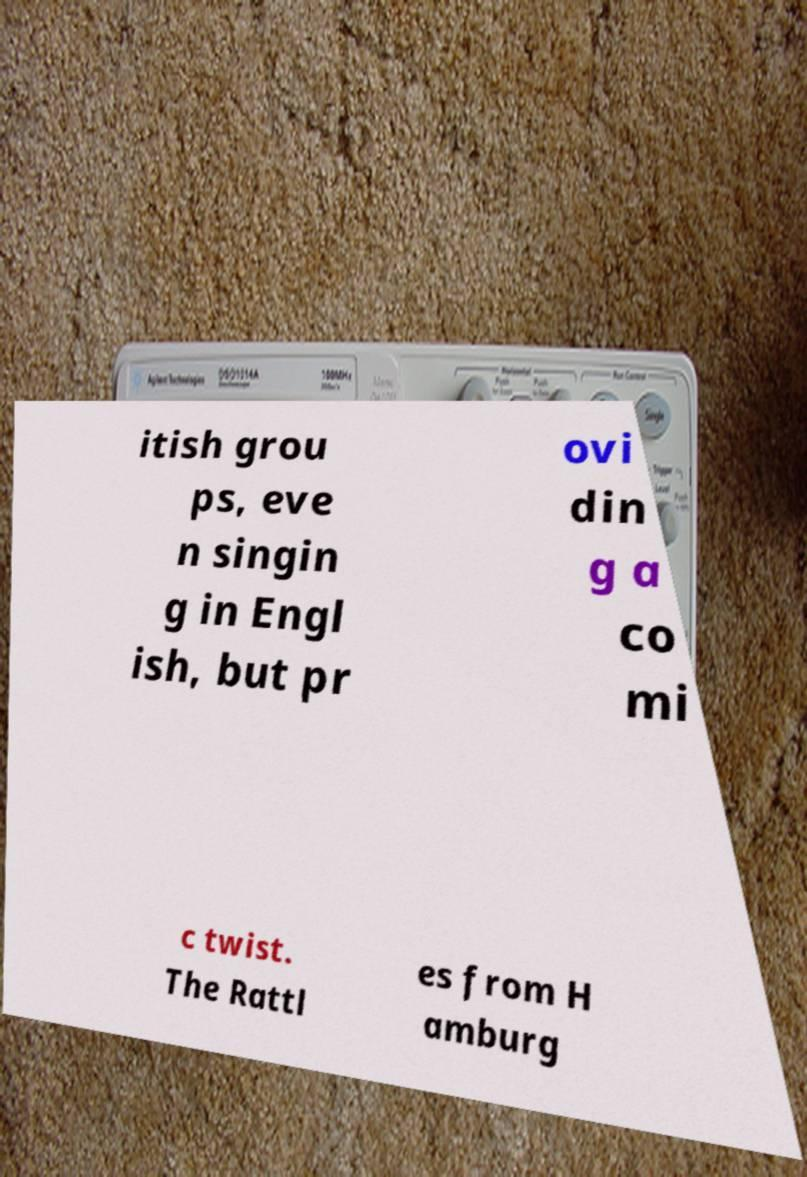Please read and relay the text visible in this image. What does it say? itish grou ps, eve n singin g in Engl ish, but pr ovi din g a co mi c twist. The Rattl es from H amburg 